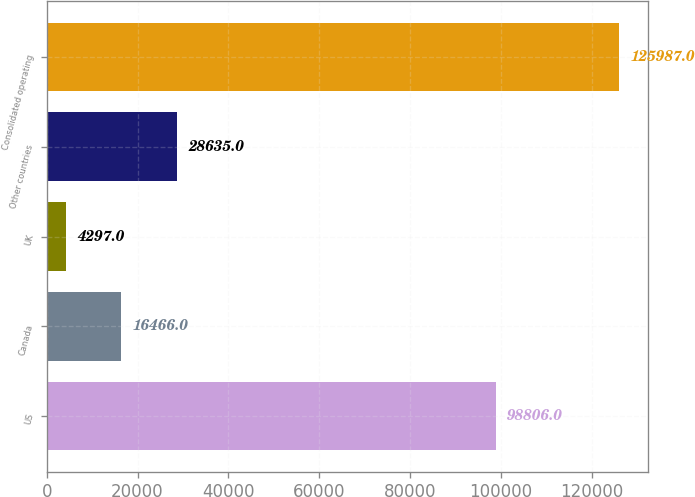Convert chart to OTSL. <chart><loc_0><loc_0><loc_500><loc_500><bar_chart><fcel>US<fcel>Canada<fcel>UK<fcel>Other countries<fcel>Consolidated operating<nl><fcel>98806<fcel>16466<fcel>4297<fcel>28635<fcel>125987<nl></chart> 